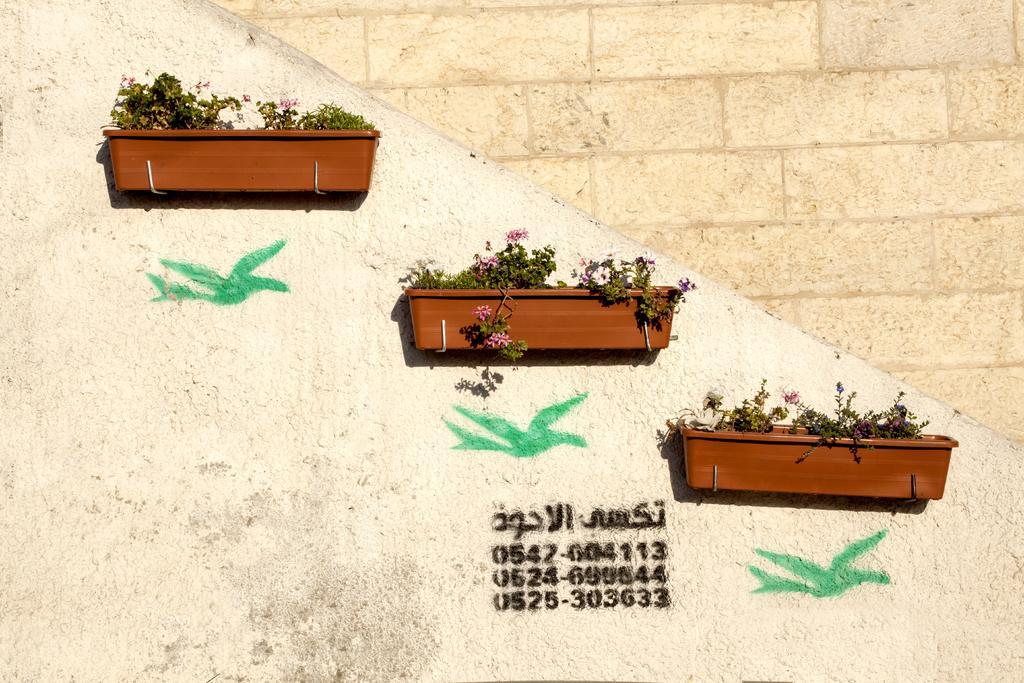In one or two sentences, can you explain what this image depicts? There are three plant pots are attached to the wall in the middle of this image. We can see numerical numbers and some text written on the wall. 